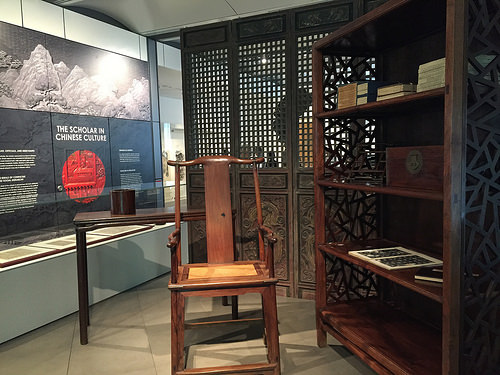<image>
Can you confirm if the chair is behind the table? No. The chair is not behind the table. From this viewpoint, the chair appears to be positioned elsewhere in the scene. Is the table in front of the chair? No. The table is not in front of the chair. The spatial positioning shows a different relationship between these objects. 